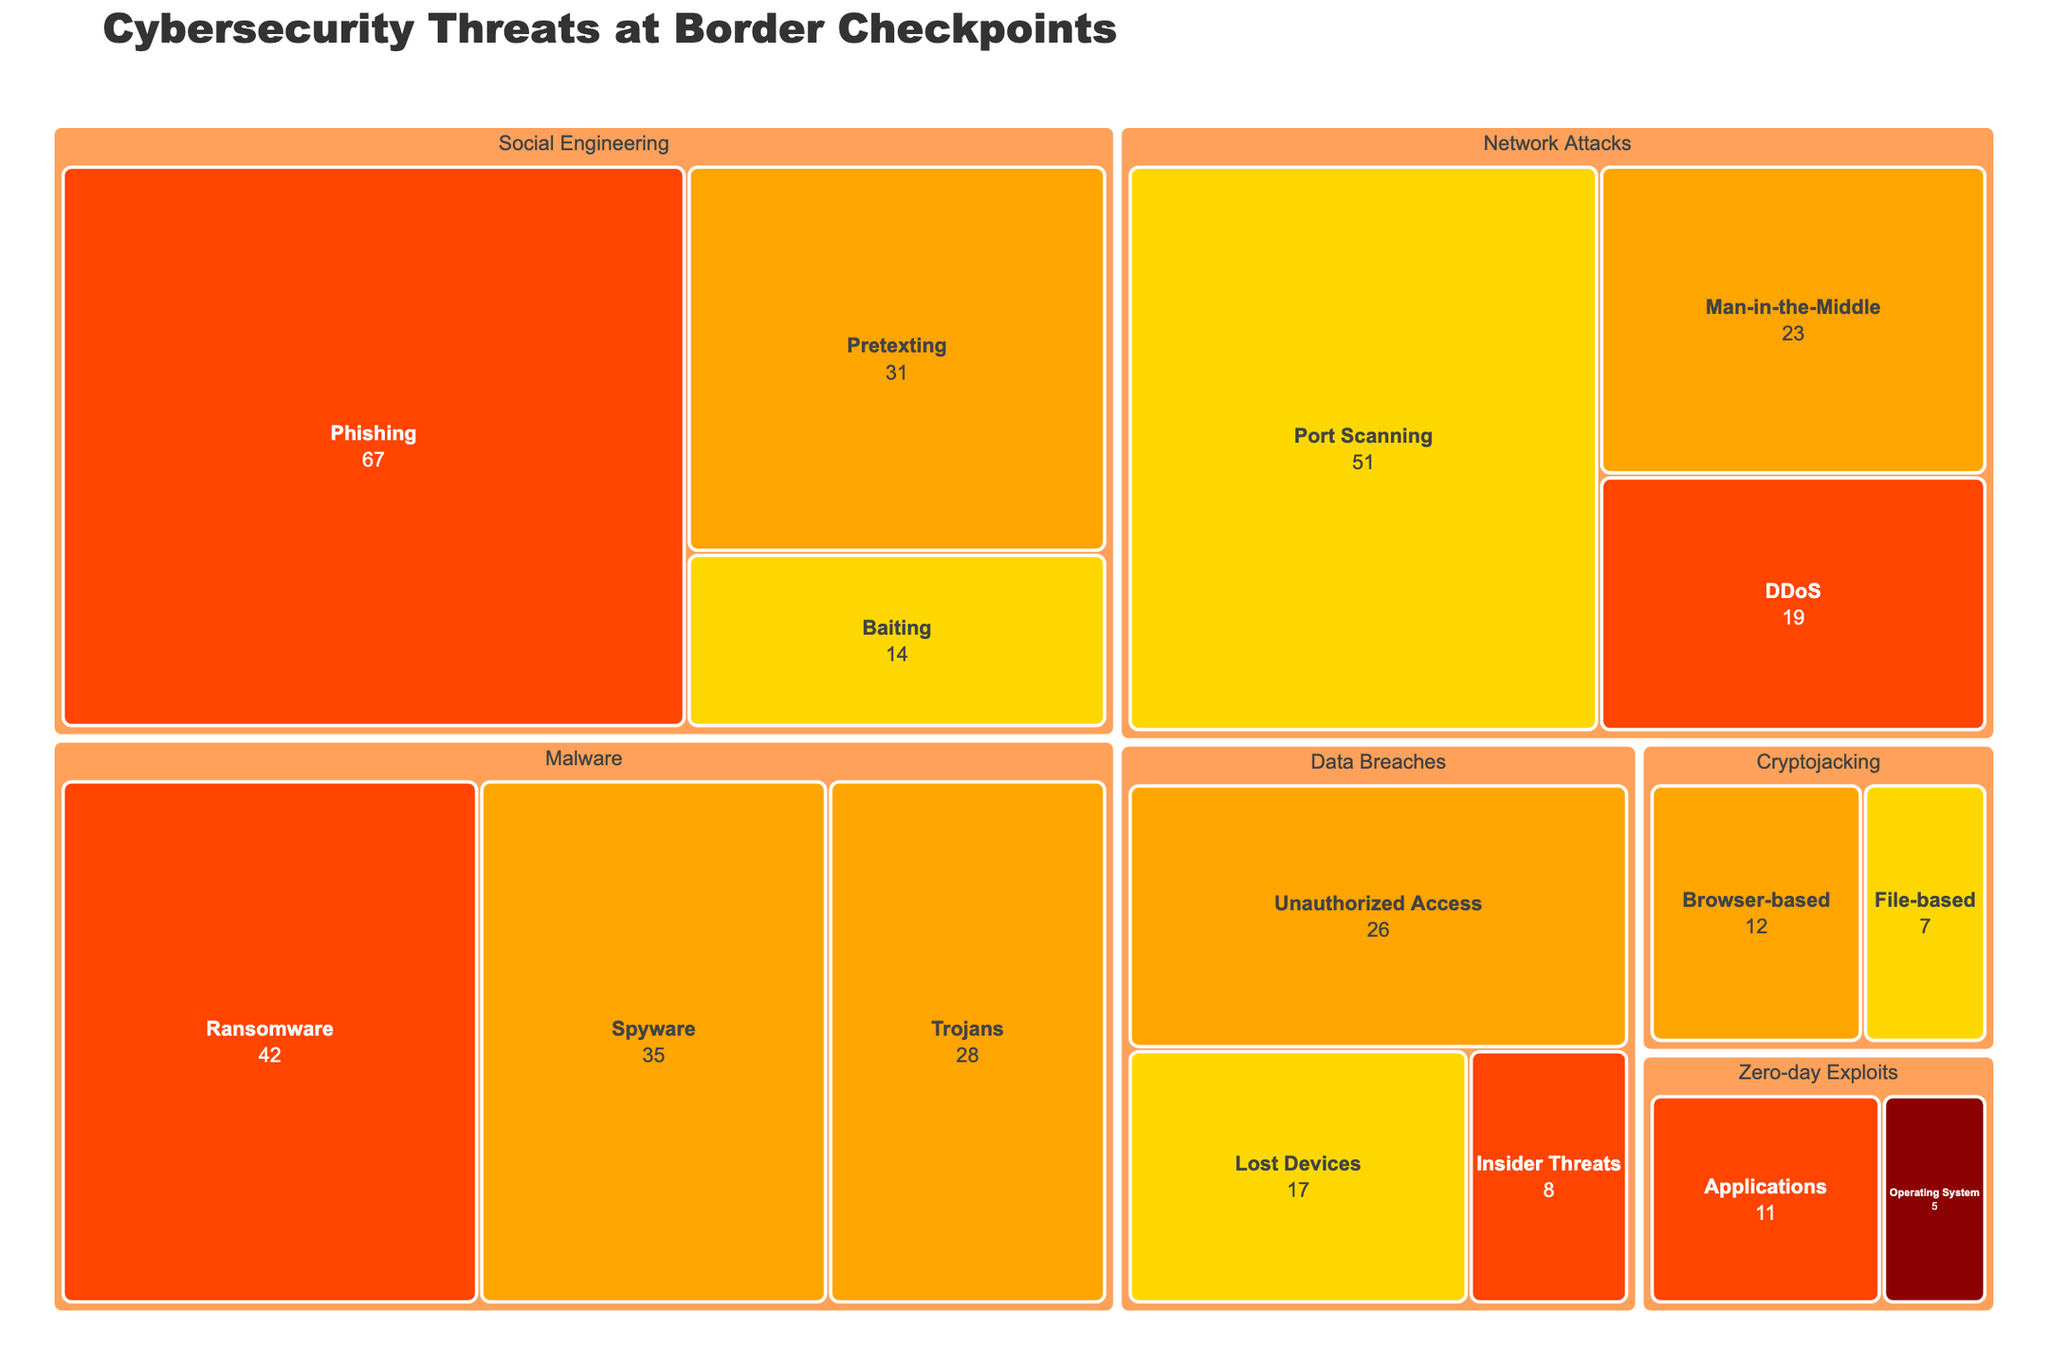What is the title of the treemap figure? The title is typically displayed prominently at the top of the figure. In this case, the title text provided in the layout settings is 'Cybersecurity Threats at Border Checkpoints'.
Answer: Cybersecurity Threats at Border Checkpoints What category has the highest number of detected threats? By examining the treemap, we can compare the area of different categories. 'Social Engineering' has the largest area, indicating it has the highest number of detected threats.
Answer: Social Engineering Which subcategory within Network Attacks has the highest threat count? Within the Network Attacks category, the subcategory with the largest area represents the highest count. 'Port Scanning' has the highest count.
Answer: Port Scanning How many High severity threats are present in Malware? In the Malware category, we can see the subcategories and their severities. The High severity subcategory is 'Ransomware' with a count of 42.
Answer: 42 What is the total count of Medium severity threats across all categories? We need to sum all Medium severity threats: Trojans (28) + Spyware (35) + Man-in-the-Middle (23) + Pretexting (31) + Unauthorized Access (26) + Browser-based (12). The sum is 28 + 35 + 23 + 31 + 26 + 12.
Answer: 155 Which category has the smallest number of Critical severity threats? "Zero-day Exploits" is the only category with Critical severity and has a count of 5. Since it’s the only category, it both has the smallest and largest Critical severity threats count.
Answer: Zero-day Exploits Compare the number of Low severity threats in Social Engineering and Cryptojacking. Which category has more? Low severity threats in Social Engineering are 'Baiting' (14) and in Cryptojacking are 'File-based' (7). Comparing these two counts, Social Engineering has more.
Answer: Social Engineering What is the total number of threats detected in the Data Breaches category? Sum the counts of all subcategories within 'Data Breaches': Insider Threats (8) + Unauthorized Access (26) + Lost Devices (17). The sum is 8 + 26 + 17.
Answer: 51 Explain why 'Phishing' might be a cause for concern in the Social Engineering category. 'Phishing' has the highest count (67) among its subcategories and the entire treemap, indicating a significant frequency. High severity further emphasizes its critical nature, reflecting the high potential risk and urgency to address.
Answer: Highest count and high severity (67) How does the count of High severity threats in 'Social Engineering' compare to that in 'Malware'? In Social Engineering, High severity threats are 'Phishing' (67), in Malware are 'Ransomware' (42). Compare these values: 67 is greater than 42.
Answer: Social Engineering has more 